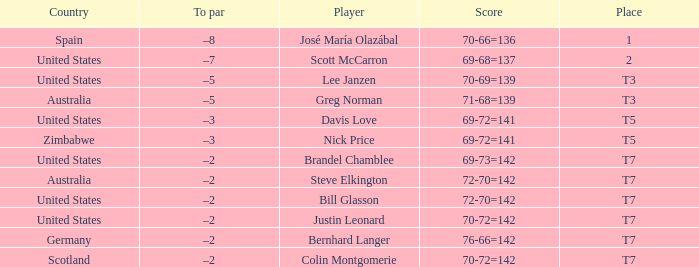Parse the table in full. {'header': ['Country', 'To par', 'Player', 'Score', 'Place'], 'rows': [['Spain', '–8', 'José María Olazábal', '70-66=136', '1'], ['United States', '–7', 'Scott McCarron', '69-68=137', '2'], ['United States', '–5', 'Lee Janzen', '70-69=139', 'T3'], ['Australia', '–5', 'Greg Norman', '71-68=139', 'T3'], ['United States', '–3', 'Davis Love', '69-72=141', 'T5'], ['Zimbabwe', '–3', 'Nick Price', '69-72=141', 'T5'], ['United States', '–2', 'Brandel Chamblee', '69-73=142', 'T7'], ['Australia', '–2', 'Steve Elkington', '72-70=142', 'T7'], ['United States', '–2', 'Bill Glasson', '72-70=142', 'T7'], ['United States', '–2', 'Justin Leonard', '70-72=142', 'T7'], ['Germany', '–2', 'Bernhard Langer', '76-66=142', 'T7'], ['Scotland', '–2', 'Colin Montgomerie', '70-72=142', 'T7']]} Name the Player who has a To par of –2 and a Score of 69-73=142? Brandel Chamblee. 